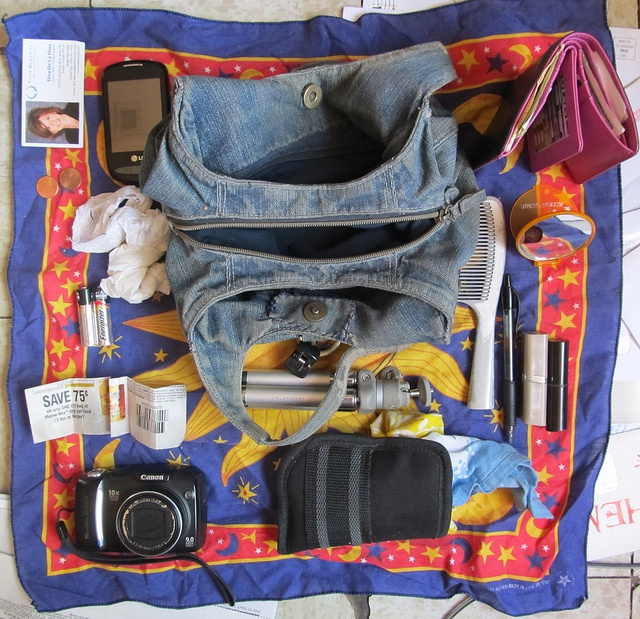Describe the objects in this image and their specific colors. I can see handbag in lightgray, gray, darkgray, and black tones and cell phone in lightgray, black, gray, and brown tones in this image. 